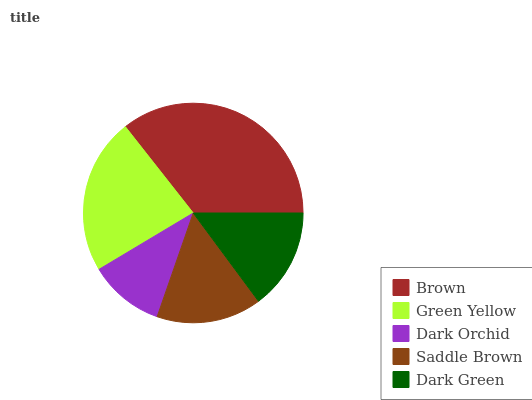Is Dark Orchid the minimum?
Answer yes or no. Yes. Is Brown the maximum?
Answer yes or no. Yes. Is Green Yellow the minimum?
Answer yes or no. No. Is Green Yellow the maximum?
Answer yes or no. No. Is Brown greater than Green Yellow?
Answer yes or no. Yes. Is Green Yellow less than Brown?
Answer yes or no. Yes. Is Green Yellow greater than Brown?
Answer yes or no. No. Is Brown less than Green Yellow?
Answer yes or no. No. Is Saddle Brown the high median?
Answer yes or no. Yes. Is Saddle Brown the low median?
Answer yes or no. Yes. Is Brown the high median?
Answer yes or no. No. Is Brown the low median?
Answer yes or no. No. 